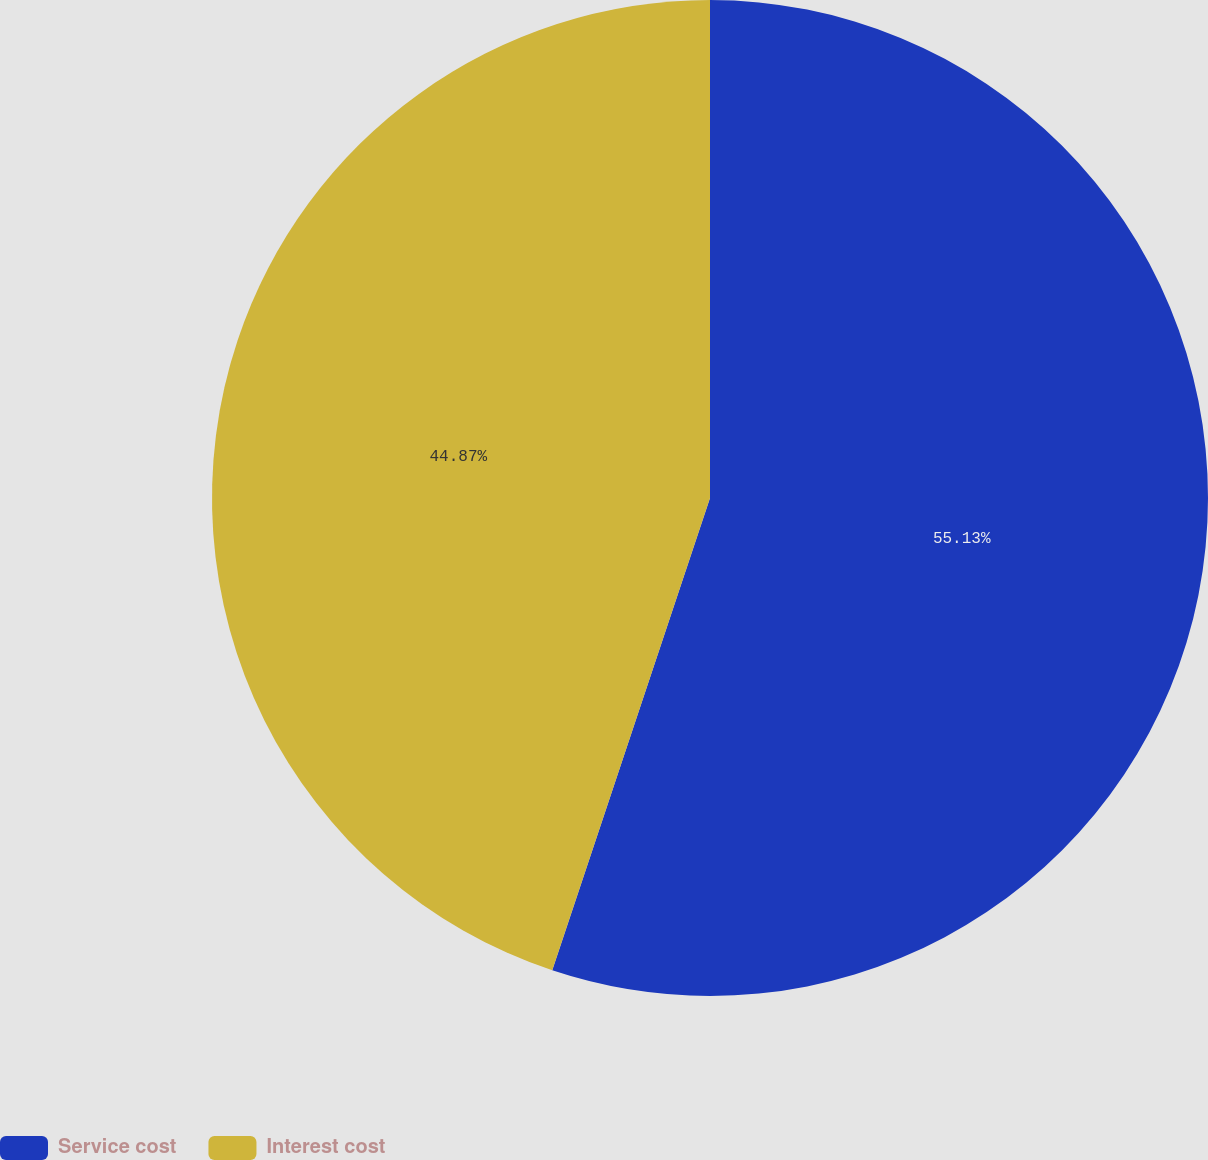<chart> <loc_0><loc_0><loc_500><loc_500><pie_chart><fcel>Service cost<fcel>Interest cost<nl><fcel>55.13%<fcel>44.87%<nl></chart> 